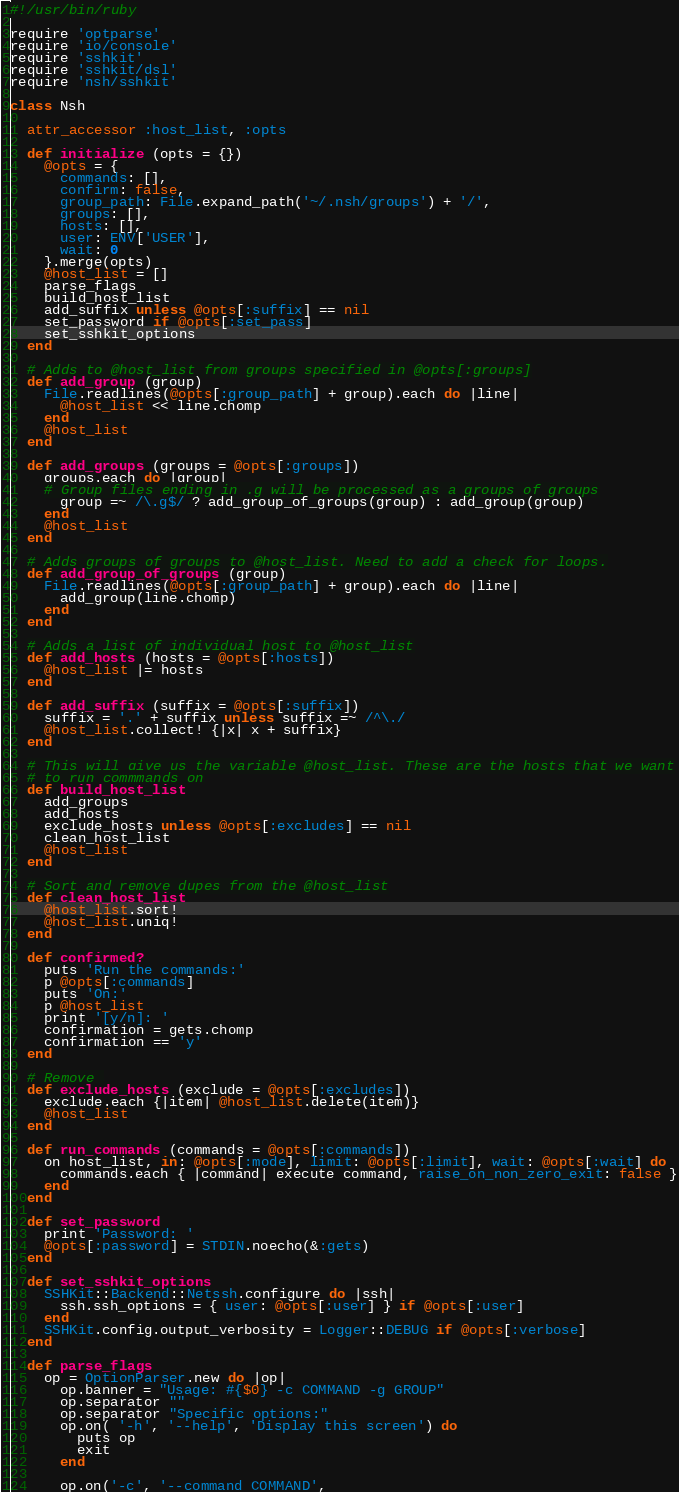<code> <loc_0><loc_0><loc_500><loc_500><_Ruby_>#!/usr/bin/ruby

require 'optparse'
require 'io/console'
require 'sshkit'
require 'sshkit/dsl'
require 'nsh/sshkit'

class Nsh

  attr_accessor :host_list, :opts
  
  def initialize (opts = {})
    @opts = {
      commands: [],
      confirm: false,
      group_path: File.expand_path('~/.nsh/groups') + '/',
      groups: [],
      hosts: [],
      user: ENV['USER'],
      wait: 0
    }.merge(opts)
    @host_list = []
    parse_flags
    build_host_list
    add_suffix unless @opts[:suffix] == nil
    set_password if @opts[:set_pass]
    set_sshkit_options
  end

  # Adds to @host_list from groups specified in @opts[:groups]
  def add_group (group)
    File.readlines(@opts[:group_path] + group).each do |line| 
      @host_list << line.chomp
    end
    @host_list
  end

  def add_groups (groups = @opts[:groups])
    groups.each do |group|
    # Group files ending in .g will be processed as a groups of groups
      group =~ /\.g$/ ? add_group_of_groups(group) : add_group(group)
    end
    @host_list
  end

  # Adds groups of groups to @host_list. Need to add a check for loops.
  def add_group_of_groups (group)
    File.readlines(@opts[:group_path] + group).each do |line|
      add_group(line.chomp)
    end
  end

  # Adds a list of individual host to @host_list
  def add_hosts (hosts = @opts[:hosts])
    @host_list |= hosts
  end

  def add_suffix (suffix = @opts[:suffix])
    suffix = '.' + suffix unless suffix =~ /^\./
    @host_list.collect! {|x| x + suffix}
  end

  # This will give us the variable @host_list. These are the hosts that we want
  # to run commmands on
  def build_host_list
    add_groups
    add_hosts
    exclude_hosts unless @opts[:excludes] == nil
    clean_host_list
    @host_list
  end

  # Sort and remove dupes from the @host_list
  def clean_host_list 
    @host_list.sort!
    @host_list.uniq!
  end

  def confirmed?
    puts 'Run the commands:'
    p @opts[:commands]
    puts 'On:'
    p @host_list
    print '[y/n]: '
    confirmation = gets.chomp
    confirmation == 'y'
  end

  # Remove 
  def exclude_hosts (exclude = @opts[:excludes])
    exclude.each {|item| @host_list.delete(item)}
    @host_list
  end

  def run_commands (commands = @opts[:commands])
    on host_list, in: @opts[:mode], limit: @opts[:limit], wait: @opts[:wait] do
      commands.each { |command| execute command, raise_on_non_zero_exit: false }
    end
  end

  def set_password
    print 'Password: '
    @opts[:password] = STDIN.noecho(&:gets)
  end

  def set_sshkit_options
    SSHKit::Backend::Netssh.configure do |ssh|
      ssh.ssh_options = { user: @opts[:user] } if @opts[:user]
    end
    SSHKit.config.output_verbosity = Logger::DEBUG if @opts[:verbose]
  end

  def parse_flags
    op = OptionParser.new do |op|
      op.banner = "Usage: #{$0} -c COMMAND -g GROUP"
      op.separator ""
      op.separator "Specific options:"
      op.on( '-h', '--help', 'Display this screen') do
        puts op
        exit
      end

      op.on('-c', '--command COMMAND',</code> 